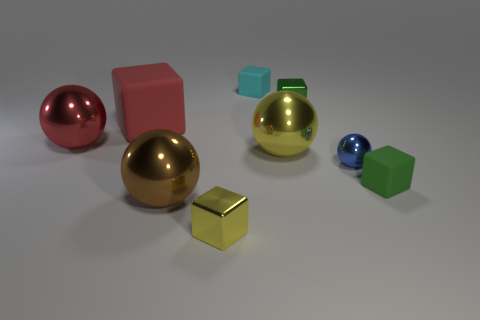Are there more brown metallic balls on the right side of the small green rubber block than tiny purple shiny blocks?
Your answer should be very brief. No. There is a tiny matte object behind the yellow thing that is on the right side of the cyan rubber object; how many small green metallic cubes are behind it?
Ensure brevity in your answer.  0. There is a ball that is in front of the small green matte block; is its size the same as the yellow object that is in front of the yellow shiny ball?
Your answer should be very brief. No. What is the material of the large cube behind the metallic object that is left of the brown metallic ball?
Your answer should be compact. Rubber. What number of things are either rubber objects to the left of the large brown sphere or tiny cyan metal cylinders?
Keep it short and to the point. 1. Are there an equal number of cubes that are right of the yellow cube and red balls that are in front of the big yellow ball?
Your response must be concise. No. There is a green cube in front of the blue ball that is on the right side of the tiny metal cube that is left of the small cyan thing; what is it made of?
Keep it short and to the point. Rubber. There is a ball that is both behind the tiny blue shiny object and right of the tiny cyan cube; what is its size?
Ensure brevity in your answer.  Large. Is the shape of the cyan rubber thing the same as the small green matte thing?
Provide a succinct answer. Yes. What shape is the big red object that is the same material as the cyan object?
Ensure brevity in your answer.  Cube. 